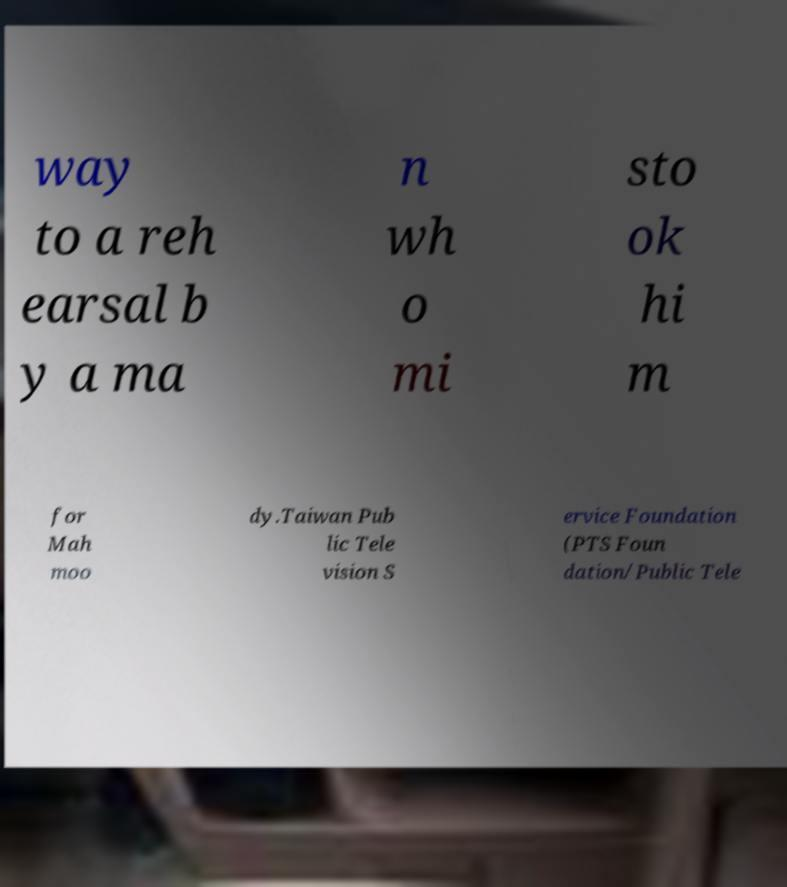For documentation purposes, I need the text within this image transcribed. Could you provide that? way to a reh earsal b y a ma n wh o mi sto ok hi m for Mah moo dy.Taiwan Pub lic Tele vision S ervice Foundation (PTS Foun dation/Public Tele 